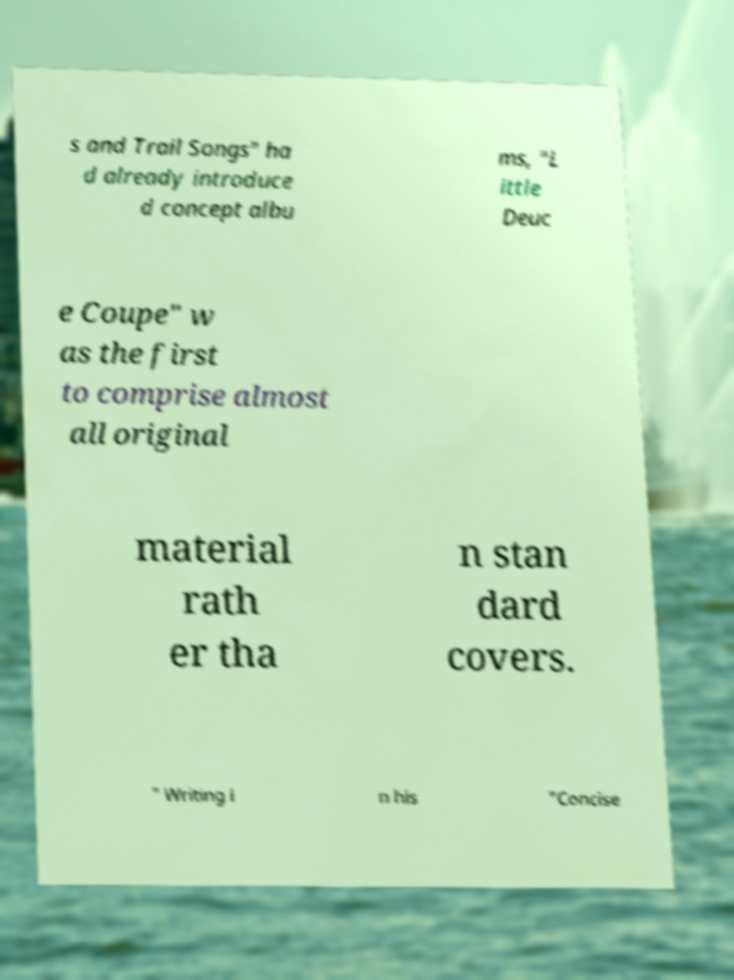I need the written content from this picture converted into text. Can you do that? s and Trail Songs" ha d already introduce d concept albu ms, "L ittle Deuc e Coupe" w as the first to comprise almost all original material rath er tha n stan dard covers. " Writing i n his "Concise 